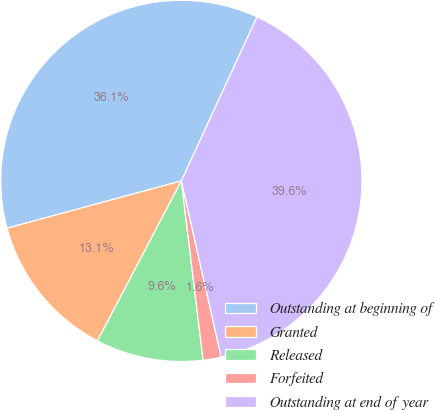<chart> <loc_0><loc_0><loc_500><loc_500><pie_chart><fcel>Outstanding at beginning of<fcel>Granted<fcel>Released<fcel>Forfeited<fcel>Outstanding at end of year<nl><fcel>36.1%<fcel>13.09%<fcel>9.61%<fcel>1.62%<fcel>39.58%<nl></chart> 